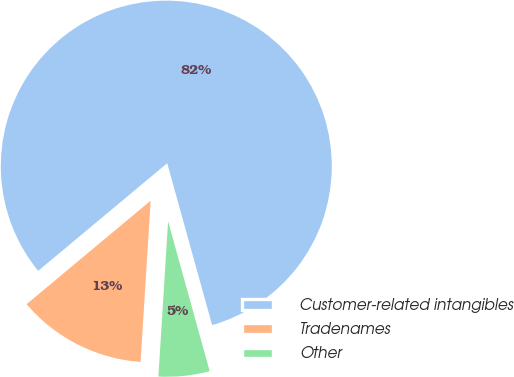Convert chart. <chart><loc_0><loc_0><loc_500><loc_500><pie_chart><fcel>Customer-related intangibles<fcel>Tradenames<fcel>Other<nl><fcel>81.76%<fcel>12.94%<fcel>5.3%<nl></chart> 